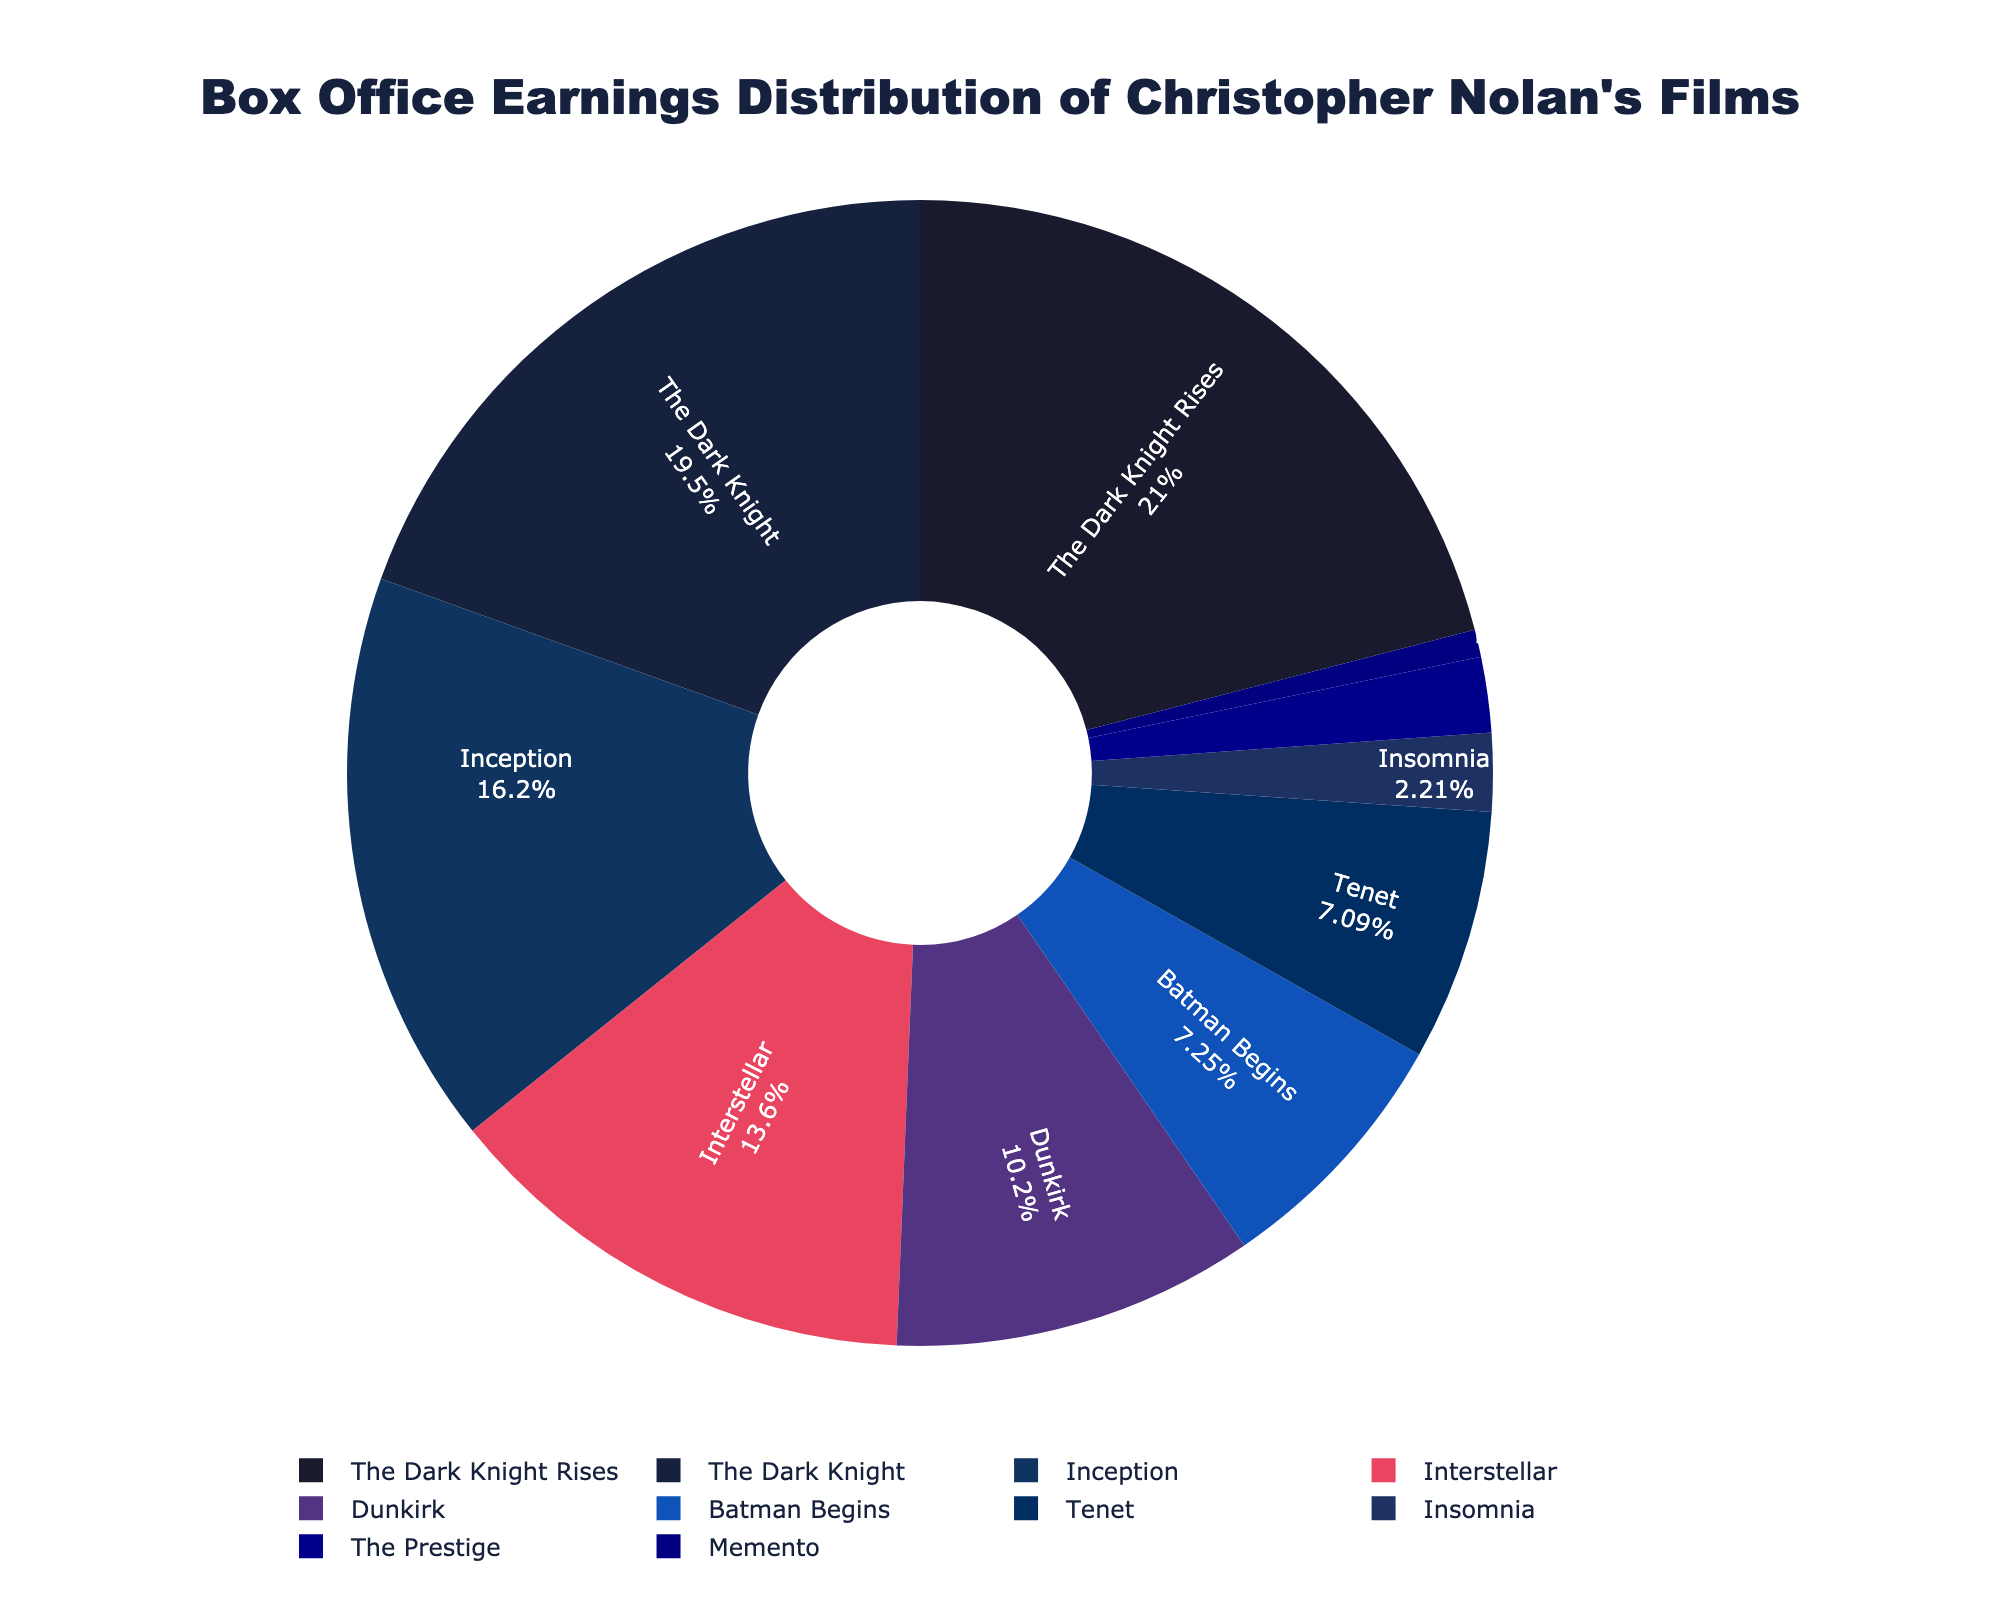What percentage of the total box office earnings did "Inception" earn? "Inception" is a labeled segment in the pie chart, and the percentage is displayed within the segment. Locate "Inception" and read off the percentage.
Answer: 16.6% Which film earned more at the box office, "Interstellar" or "Dunkirk"? Locate the segments labeled "Interstellar" and "Dunkirk" on the pie chart and compare their relative sizes. The percentage labels can also be checked to confirm the earnings.
Answer: Interstellar Which two films have the smallest box office earnings? Identify the two smallest segments in the pie chart. The size of the segments represents the earnings, and the films with the smallest sizes are the ones with the smallest earnings.
Answer: Memento and The Prestige What is the combined box office earnings of "The Dark Knight" and "The Dark Knight Rises"? Locate the segments labeled "The Dark Knight" and "The Dark Knight Rises." Add their box office earnings: 1004.6 (The Dark Knight) + 1081.0 (The Dark Knight Rises).
Answer: 2085.6 Which film earned more, "Batman Begins" or "Tenet"? Compare the "Batman Begins" and "Tenet" segments on the pie chart. The segment with the larger size and higher percentage reflects the film with higher earnings.
Answer: Batman Begins Is "Dunkirk" within the top three highest-grossing films? Identify the three largest segments on the pie chart and check if "Dunkirk" is among them.
Answer: No How do the earnings of the lowest-grossing film compare to the highest-grossing film? Locate the segments of the lowest-grossing film ("Memento") and the highest-grossing film ("The Dark Knight Rises"). Compare their sizes and earnings: 1081.0 (The Dark Knight Rises) vs. 39.7 (Memento).
Answer: The lowest-grossing film earned significantly less than the highest-grossing film Rank the films "Inception," "Interstellar," and "Dunkirk" according to their box office earnings from highest to lowest. Identify and compare the segments for "Inception," "Interstellar," and "Dunkirk." Rank them based on the size of the segments and the earnings percentages.
Answer: Inception, Interstellar, Dunkirk Which film between "Tenet" and "Dunkirk" has a greater share of the pie chart? Compare the size of "Tenet" and "Dunkirk" segments and the percentage labels to determine which has a greater share.
Answer: Dunkirk Calculate the average box office earnings of "Memento," "Insomnia," and "The Prestige." Add the box office earnings for "Memento" (39.7), "Insomnia" (113.7), and "The Prestige" (109.7), and divide by 3 to find the average: (39.7 + 113.7 + 109.7) / 3.
Answer: 87.7 